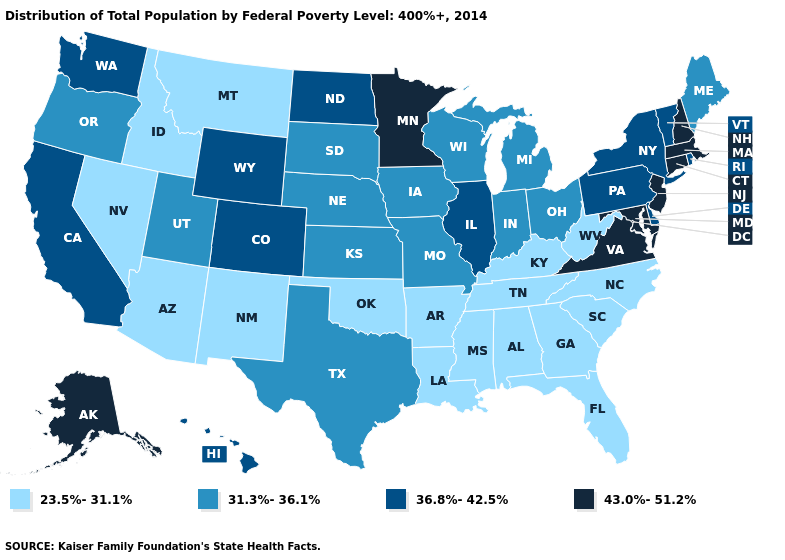Does Idaho have a higher value than New Mexico?
Write a very short answer. No. Is the legend a continuous bar?
Quick response, please. No. Is the legend a continuous bar?
Concise answer only. No. What is the value of Nevada?
Answer briefly. 23.5%-31.1%. What is the value of Montana?
Short answer required. 23.5%-31.1%. What is the value of Pennsylvania?
Quick response, please. 36.8%-42.5%. Name the states that have a value in the range 36.8%-42.5%?
Be succinct. California, Colorado, Delaware, Hawaii, Illinois, New York, North Dakota, Pennsylvania, Rhode Island, Vermont, Washington, Wyoming. What is the value of Delaware?
Be succinct. 36.8%-42.5%. What is the highest value in the USA?
Concise answer only. 43.0%-51.2%. Which states have the lowest value in the West?
Quick response, please. Arizona, Idaho, Montana, Nevada, New Mexico. Does Virginia have the highest value in the USA?
Keep it brief. Yes. Does the first symbol in the legend represent the smallest category?
Answer briefly. Yes. Does South Carolina have the lowest value in the USA?
Keep it brief. Yes. Name the states that have a value in the range 31.3%-36.1%?
Concise answer only. Indiana, Iowa, Kansas, Maine, Michigan, Missouri, Nebraska, Ohio, Oregon, South Dakota, Texas, Utah, Wisconsin. What is the value of Utah?
Concise answer only. 31.3%-36.1%. 